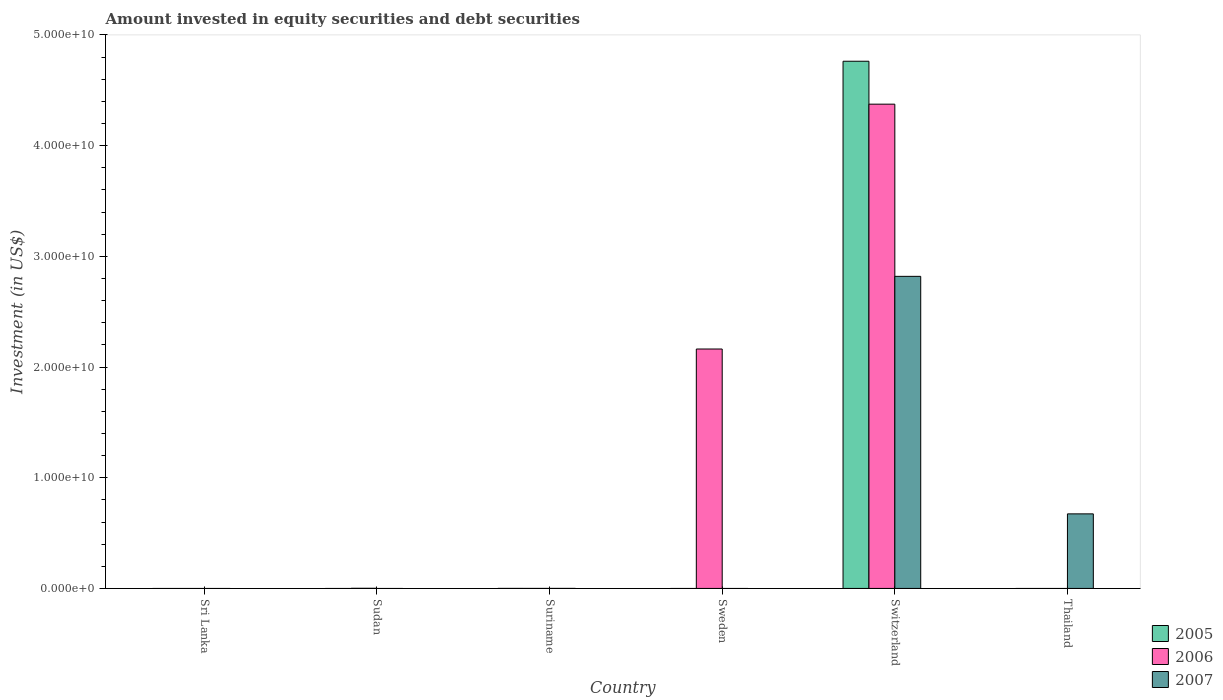How many different coloured bars are there?
Provide a succinct answer. 3. How many bars are there on the 4th tick from the left?
Ensure brevity in your answer.  1. What is the label of the 5th group of bars from the left?
Ensure brevity in your answer.  Switzerland. What is the amount invested in equity securities and debt securities in 2007 in Sri Lanka?
Offer a very short reply. 0. Across all countries, what is the maximum amount invested in equity securities and debt securities in 2007?
Your response must be concise. 2.82e+1. Across all countries, what is the minimum amount invested in equity securities and debt securities in 2007?
Provide a short and direct response. 0. In which country was the amount invested in equity securities and debt securities in 2007 maximum?
Offer a very short reply. Switzerland. What is the total amount invested in equity securities and debt securities in 2007 in the graph?
Your answer should be compact. 3.49e+1. What is the difference between the amount invested in equity securities and debt securities in 2005 in Suriname and that in Switzerland?
Ensure brevity in your answer.  -4.76e+1. What is the difference between the amount invested in equity securities and debt securities in 2006 in Sweden and the amount invested in equity securities and debt securities in 2005 in Thailand?
Offer a terse response. 2.16e+1. What is the average amount invested in equity securities and debt securities in 2005 per country?
Your answer should be very brief. 7.94e+09. What is the difference between the amount invested in equity securities and debt securities of/in 2005 and amount invested in equity securities and debt securities of/in 2007 in Switzerland?
Make the answer very short. 1.94e+1. In how many countries, is the amount invested in equity securities and debt securities in 2006 greater than 44000000000 US$?
Make the answer very short. 0. What is the ratio of the amount invested in equity securities and debt securities in 2006 in Sudan to that in Switzerland?
Ensure brevity in your answer.  0. What is the difference between the highest and the second highest amount invested in equity securities and debt securities in 2006?
Provide a short and direct response. 4.37e+1. What is the difference between the highest and the lowest amount invested in equity securities and debt securities in 2005?
Provide a short and direct response. 4.76e+1. In how many countries, is the amount invested in equity securities and debt securities in 2007 greater than the average amount invested in equity securities and debt securities in 2007 taken over all countries?
Offer a terse response. 2. How many bars are there?
Provide a succinct answer. 9. Does the graph contain grids?
Your response must be concise. No. How many legend labels are there?
Ensure brevity in your answer.  3. How are the legend labels stacked?
Your response must be concise. Vertical. What is the title of the graph?
Offer a terse response. Amount invested in equity securities and debt securities. What is the label or title of the Y-axis?
Your answer should be very brief. Investment (in US$). What is the Investment (in US$) in 2005 in Sri Lanka?
Give a very brief answer. 0. What is the Investment (in US$) in 2007 in Sri Lanka?
Keep it short and to the point. 0. What is the Investment (in US$) of 2006 in Sudan?
Your answer should be compact. 1.22e+07. What is the Investment (in US$) of 2007 in Sudan?
Provide a short and direct response. 0. What is the Investment (in US$) in 2006 in Suriname?
Ensure brevity in your answer.  3.00e+05. What is the Investment (in US$) of 2007 in Suriname?
Your answer should be very brief. 1.30e+06. What is the Investment (in US$) of 2006 in Sweden?
Your answer should be compact. 2.16e+1. What is the Investment (in US$) in 2007 in Sweden?
Provide a succinct answer. 0. What is the Investment (in US$) of 2005 in Switzerland?
Ensure brevity in your answer.  4.76e+1. What is the Investment (in US$) in 2006 in Switzerland?
Give a very brief answer. 4.37e+1. What is the Investment (in US$) in 2007 in Switzerland?
Give a very brief answer. 2.82e+1. What is the Investment (in US$) in 2005 in Thailand?
Your response must be concise. 0. What is the Investment (in US$) of 2006 in Thailand?
Your response must be concise. 0. What is the Investment (in US$) in 2007 in Thailand?
Offer a very short reply. 6.74e+09. Across all countries, what is the maximum Investment (in US$) in 2005?
Your answer should be compact. 4.76e+1. Across all countries, what is the maximum Investment (in US$) in 2006?
Give a very brief answer. 4.37e+1. Across all countries, what is the maximum Investment (in US$) in 2007?
Your response must be concise. 2.82e+1. Across all countries, what is the minimum Investment (in US$) of 2007?
Keep it short and to the point. 0. What is the total Investment (in US$) of 2005 in the graph?
Provide a short and direct response. 4.76e+1. What is the total Investment (in US$) in 2006 in the graph?
Keep it short and to the point. 6.54e+1. What is the total Investment (in US$) in 2007 in the graph?
Your response must be concise. 3.49e+1. What is the difference between the Investment (in US$) of 2006 in Sudan and that in Suriname?
Offer a very short reply. 1.19e+07. What is the difference between the Investment (in US$) in 2006 in Sudan and that in Sweden?
Give a very brief answer. -2.16e+1. What is the difference between the Investment (in US$) of 2006 in Sudan and that in Switzerland?
Your response must be concise. -4.37e+1. What is the difference between the Investment (in US$) of 2006 in Suriname and that in Sweden?
Your answer should be very brief. -2.16e+1. What is the difference between the Investment (in US$) in 2005 in Suriname and that in Switzerland?
Ensure brevity in your answer.  -4.76e+1. What is the difference between the Investment (in US$) of 2006 in Suriname and that in Switzerland?
Your response must be concise. -4.37e+1. What is the difference between the Investment (in US$) in 2007 in Suriname and that in Switzerland?
Offer a very short reply. -2.82e+1. What is the difference between the Investment (in US$) in 2007 in Suriname and that in Thailand?
Your answer should be compact. -6.73e+09. What is the difference between the Investment (in US$) of 2006 in Sweden and that in Switzerland?
Offer a very short reply. -2.21e+1. What is the difference between the Investment (in US$) in 2007 in Switzerland and that in Thailand?
Your answer should be compact. 2.15e+1. What is the difference between the Investment (in US$) in 2006 in Sudan and the Investment (in US$) in 2007 in Suriname?
Give a very brief answer. 1.09e+07. What is the difference between the Investment (in US$) in 2006 in Sudan and the Investment (in US$) in 2007 in Switzerland?
Provide a short and direct response. -2.82e+1. What is the difference between the Investment (in US$) of 2006 in Sudan and the Investment (in US$) of 2007 in Thailand?
Ensure brevity in your answer.  -6.72e+09. What is the difference between the Investment (in US$) of 2005 in Suriname and the Investment (in US$) of 2006 in Sweden?
Provide a succinct answer. -2.16e+1. What is the difference between the Investment (in US$) of 2005 in Suriname and the Investment (in US$) of 2006 in Switzerland?
Offer a terse response. -4.37e+1. What is the difference between the Investment (in US$) in 2005 in Suriname and the Investment (in US$) in 2007 in Switzerland?
Make the answer very short. -2.82e+1. What is the difference between the Investment (in US$) of 2006 in Suriname and the Investment (in US$) of 2007 in Switzerland?
Provide a succinct answer. -2.82e+1. What is the difference between the Investment (in US$) of 2005 in Suriname and the Investment (in US$) of 2007 in Thailand?
Ensure brevity in your answer.  -6.73e+09. What is the difference between the Investment (in US$) in 2006 in Suriname and the Investment (in US$) in 2007 in Thailand?
Provide a short and direct response. -6.74e+09. What is the difference between the Investment (in US$) in 2006 in Sweden and the Investment (in US$) in 2007 in Switzerland?
Keep it short and to the point. -6.56e+09. What is the difference between the Investment (in US$) of 2006 in Sweden and the Investment (in US$) of 2007 in Thailand?
Give a very brief answer. 1.49e+1. What is the difference between the Investment (in US$) in 2005 in Switzerland and the Investment (in US$) in 2007 in Thailand?
Offer a terse response. 4.09e+1. What is the difference between the Investment (in US$) in 2006 in Switzerland and the Investment (in US$) in 2007 in Thailand?
Offer a very short reply. 3.70e+1. What is the average Investment (in US$) of 2005 per country?
Your answer should be compact. 7.94e+09. What is the average Investment (in US$) of 2006 per country?
Your response must be concise. 1.09e+1. What is the average Investment (in US$) of 2007 per country?
Your answer should be compact. 5.82e+09. What is the difference between the Investment (in US$) of 2005 and Investment (in US$) of 2006 in Suriname?
Keep it short and to the point. 1.70e+06. What is the difference between the Investment (in US$) of 2005 and Investment (in US$) of 2007 in Suriname?
Make the answer very short. 7.00e+05. What is the difference between the Investment (in US$) in 2005 and Investment (in US$) in 2006 in Switzerland?
Provide a succinct answer. 3.88e+09. What is the difference between the Investment (in US$) in 2005 and Investment (in US$) in 2007 in Switzerland?
Offer a terse response. 1.94e+1. What is the difference between the Investment (in US$) of 2006 and Investment (in US$) of 2007 in Switzerland?
Keep it short and to the point. 1.56e+1. What is the ratio of the Investment (in US$) of 2006 in Sudan to that in Suriname?
Give a very brief answer. 40.54. What is the ratio of the Investment (in US$) of 2006 in Sudan to that in Sweden?
Provide a short and direct response. 0. What is the ratio of the Investment (in US$) of 2006 in Sudan to that in Switzerland?
Provide a succinct answer. 0. What is the ratio of the Investment (in US$) of 2006 in Suriname to that in Sweden?
Offer a very short reply. 0. What is the ratio of the Investment (in US$) in 2007 in Suriname to that in Switzerland?
Give a very brief answer. 0. What is the ratio of the Investment (in US$) in 2006 in Sweden to that in Switzerland?
Ensure brevity in your answer.  0.49. What is the ratio of the Investment (in US$) of 2007 in Switzerland to that in Thailand?
Keep it short and to the point. 4.19. What is the difference between the highest and the second highest Investment (in US$) in 2006?
Offer a terse response. 2.21e+1. What is the difference between the highest and the second highest Investment (in US$) in 2007?
Provide a succinct answer. 2.15e+1. What is the difference between the highest and the lowest Investment (in US$) in 2005?
Offer a very short reply. 4.76e+1. What is the difference between the highest and the lowest Investment (in US$) of 2006?
Give a very brief answer. 4.37e+1. What is the difference between the highest and the lowest Investment (in US$) in 2007?
Give a very brief answer. 2.82e+1. 